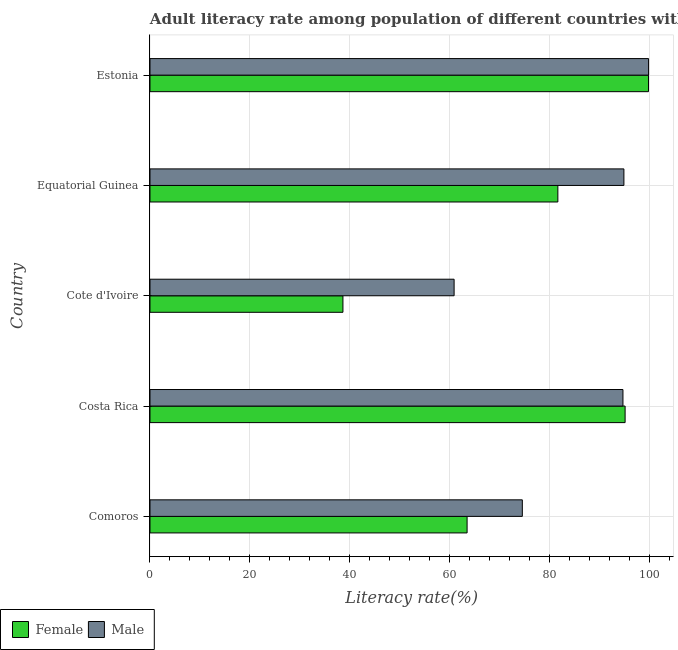How many groups of bars are there?
Give a very brief answer. 5. Are the number of bars on each tick of the Y-axis equal?
Keep it short and to the point. Yes. How many bars are there on the 2nd tick from the top?
Provide a short and direct response. 2. How many bars are there on the 3rd tick from the bottom?
Your answer should be very brief. 2. What is the label of the 5th group of bars from the top?
Make the answer very short. Comoros. In how many cases, is the number of bars for a given country not equal to the number of legend labels?
Make the answer very short. 0. What is the female adult literacy rate in Cote d'Ivoire?
Offer a terse response. 38.61. Across all countries, what is the maximum female adult literacy rate?
Make the answer very short. 99.76. Across all countries, what is the minimum female adult literacy rate?
Keep it short and to the point. 38.61. In which country was the female adult literacy rate maximum?
Ensure brevity in your answer.  Estonia. In which country was the male adult literacy rate minimum?
Make the answer very short. Cote d'Ivoire. What is the total female adult literacy rate in the graph?
Your response must be concise. 378.54. What is the difference between the male adult literacy rate in Costa Rica and that in Equatorial Guinea?
Make the answer very short. -0.19. What is the difference between the female adult literacy rate in Equatorial Guinea and the male adult literacy rate in Comoros?
Your response must be concise. 7.11. What is the average male adult literacy rate per country?
Give a very brief answer. 84.93. What is the difference between the male adult literacy rate and female adult literacy rate in Costa Rica?
Provide a short and direct response. -0.43. In how many countries, is the male adult literacy rate greater than 84 %?
Keep it short and to the point. 3. What is the ratio of the female adult literacy rate in Cote d'Ivoire to that in Estonia?
Offer a terse response. 0.39. Is the male adult literacy rate in Cote d'Ivoire less than that in Equatorial Guinea?
Keep it short and to the point. Yes. What is the difference between the highest and the second highest female adult literacy rate?
Give a very brief answer. 4.68. What is the difference between the highest and the lowest female adult literacy rate?
Ensure brevity in your answer.  61.15. Is the sum of the male adult literacy rate in Cote d'Ivoire and Estonia greater than the maximum female adult literacy rate across all countries?
Ensure brevity in your answer.  Yes. What does the 1st bar from the bottom in Estonia represents?
Keep it short and to the point. Female. Are all the bars in the graph horizontal?
Your answer should be very brief. Yes. What is the difference between two consecutive major ticks on the X-axis?
Provide a succinct answer. 20. Does the graph contain grids?
Keep it short and to the point. Yes. How many legend labels are there?
Make the answer very short. 2. What is the title of the graph?
Offer a terse response. Adult literacy rate among population of different countries with age above 15years. What is the label or title of the X-axis?
Offer a very short reply. Literacy rate(%). What is the Literacy rate(%) of Female in Comoros?
Give a very brief answer. 63.46. What is the Literacy rate(%) in Male in Comoros?
Your answer should be very brief. 74.51. What is the Literacy rate(%) in Female in Costa Rica?
Ensure brevity in your answer.  95.08. What is the Literacy rate(%) in Male in Costa Rica?
Your answer should be compact. 94.65. What is the Literacy rate(%) of Female in Cote d'Ivoire?
Your response must be concise. 38.61. What is the Literacy rate(%) in Male in Cote d'Ivoire?
Provide a short and direct response. 60.86. What is the Literacy rate(%) in Female in Equatorial Guinea?
Keep it short and to the point. 81.62. What is the Literacy rate(%) in Male in Equatorial Guinea?
Make the answer very short. 94.84. What is the Literacy rate(%) in Female in Estonia?
Your answer should be very brief. 99.76. What is the Literacy rate(%) in Male in Estonia?
Provide a short and direct response. 99.78. Across all countries, what is the maximum Literacy rate(%) of Female?
Your response must be concise. 99.76. Across all countries, what is the maximum Literacy rate(%) of Male?
Offer a terse response. 99.78. Across all countries, what is the minimum Literacy rate(%) in Female?
Keep it short and to the point. 38.61. Across all countries, what is the minimum Literacy rate(%) in Male?
Keep it short and to the point. 60.86. What is the total Literacy rate(%) in Female in the graph?
Make the answer very short. 378.54. What is the total Literacy rate(%) of Male in the graph?
Offer a terse response. 424.64. What is the difference between the Literacy rate(%) in Female in Comoros and that in Costa Rica?
Keep it short and to the point. -31.62. What is the difference between the Literacy rate(%) in Male in Comoros and that in Costa Rica?
Ensure brevity in your answer.  -20.14. What is the difference between the Literacy rate(%) of Female in Comoros and that in Cote d'Ivoire?
Offer a very short reply. 24.84. What is the difference between the Literacy rate(%) of Male in Comoros and that in Cote d'Ivoire?
Your response must be concise. 13.65. What is the difference between the Literacy rate(%) of Female in Comoros and that in Equatorial Guinea?
Make the answer very short. -18.16. What is the difference between the Literacy rate(%) in Male in Comoros and that in Equatorial Guinea?
Offer a terse response. -20.33. What is the difference between the Literacy rate(%) of Female in Comoros and that in Estonia?
Keep it short and to the point. -36.3. What is the difference between the Literacy rate(%) of Male in Comoros and that in Estonia?
Your answer should be compact. -25.26. What is the difference between the Literacy rate(%) in Female in Costa Rica and that in Cote d'Ivoire?
Ensure brevity in your answer.  56.47. What is the difference between the Literacy rate(%) of Male in Costa Rica and that in Cote d'Ivoire?
Your response must be concise. 33.79. What is the difference between the Literacy rate(%) in Female in Costa Rica and that in Equatorial Guinea?
Give a very brief answer. 13.46. What is the difference between the Literacy rate(%) in Male in Costa Rica and that in Equatorial Guinea?
Your answer should be compact. -0.19. What is the difference between the Literacy rate(%) of Female in Costa Rica and that in Estonia?
Your response must be concise. -4.68. What is the difference between the Literacy rate(%) of Male in Costa Rica and that in Estonia?
Give a very brief answer. -5.13. What is the difference between the Literacy rate(%) in Female in Cote d'Ivoire and that in Equatorial Guinea?
Your response must be concise. -43.01. What is the difference between the Literacy rate(%) of Male in Cote d'Ivoire and that in Equatorial Guinea?
Give a very brief answer. -33.98. What is the difference between the Literacy rate(%) in Female in Cote d'Ivoire and that in Estonia?
Provide a succinct answer. -61.15. What is the difference between the Literacy rate(%) in Male in Cote d'Ivoire and that in Estonia?
Ensure brevity in your answer.  -38.92. What is the difference between the Literacy rate(%) in Female in Equatorial Guinea and that in Estonia?
Your answer should be compact. -18.14. What is the difference between the Literacy rate(%) in Male in Equatorial Guinea and that in Estonia?
Your response must be concise. -4.93. What is the difference between the Literacy rate(%) of Female in Comoros and the Literacy rate(%) of Male in Costa Rica?
Offer a terse response. -31.19. What is the difference between the Literacy rate(%) of Female in Comoros and the Literacy rate(%) of Male in Cote d'Ivoire?
Give a very brief answer. 2.6. What is the difference between the Literacy rate(%) of Female in Comoros and the Literacy rate(%) of Male in Equatorial Guinea?
Keep it short and to the point. -31.38. What is the difference between the Literacy rate(%) of Female in Comoros and the Literacy rate(%) of Male in Estonia?
Your response must be concise. -36.32. What is the difference between the Literacy rate(%) of Female in Costa Rica and the Literacy rate(%) of Male in Cote d'Ivoire?
Provide a succinct answer. 34.22. What is the difference between the Literacy rate(%) of Female in Costa Rica and the Literacy rate(%) of Male in Equatorial Guinea?
Offer a very short reply. 0.24. What is the difference between the Literacy rate(%) in Female in Costa Rica and the Literacy rate(%) in Male in Estonia?
Your response must be concise. -4.7. What is the difference between the Literacy rate(%) in Female in Cote d'Ivoire and the Literacy rate(%) in Male in Equatorial Guinea?
Provide a short and direct response. -56.23. What is the difference between the Literacy rate(%) of Female in Cote d'Ivoire and the Literacy rate(%) of Male in Estonia?
Make the answer very short. -61.16. What is the difference between the Literacy rate(%) of Female in Equatorial Guinea and the Literacy rate(%) of Male in Estonia?
Your answer should be compact. -18.15. What is the average Literacy rate(%) of Female per country?
Give a very brief answer. 75.71. What is the average Literacy rate(%) in Male per country?
Your response must be concise. 84.93. What is the difference between the Literacy rate(%) of Female and Literacy rate(%) of Male in Comoros?
Provide a succinct answer. -11.05. What is the difference between the Literacy rate(%) of Female and Literacy rate(%) of Male in Costa Rica?
Your answer should be very brief. 0.43. What is the difference between the Literacy rate(%) of Female and Literacy rate(%) of Male in Cote d'Ivoire?
Provide a short and direct response. -22.25. What is the difference between the Literacy rate(%) in Female and Literacy rate(%) in Male in Equatorial Guinea?
Your response must be concise. -13.22. What is the difference between the Literacy rate(%) of Female and Literacy rate(%) of Male in Estonia?
Make the answer very short. -0.02. What is the ratio of the Literacy rate(%) in Female in Comoros to that in Costa Rica?
Provide a succinct answer. 0.67. What is the ratio of the Literacy rate(%) of Male in Comoros to that in Costa Rica?
Give a very brief answer. 0.79. What is the ratio of the Literacy rate(%) of Female in Comoros to that in Cote d'Ivoire?
Ensure brevity in your answer.  1.64. What is the ratio of the Literacy rate(%) of Male in Comoros to that in Cote d'Ivoire?
Provide a short and direct response. 1.22. What is the ratio of the Literacy rate(%) of Female in Comoros to that in Equatorial Guinea?
Offer a terse response. 0.78. What is the ratio of the Literacy rate(%) in Male in Comoros to that in Equatorial Guinea?
Your response must be concise. 0.79. What is the ratio of the Literacy rate(%) in Female in Comoros to that in Estonia?
Offer a terse response. 0.64. What is the ratio of the Literacy rate(%) in Male in Comoros to that in Estonia?
Your answer should be very brief. 0.75. What is the ratio of the Literacy rate(%) in Female in Costa Rica to that in Cote d'Ivoire?
Ensure brevity in your answer.  2.46. What is the ratio of the Literacy rate(%) of Male in Costa Rica to that in Cote d'Ivoire?
Ensure brevity in your answer.  1.56. What is the ratio of the Literacy rate(%) of Female in Costa Rica to that in Equatorial Guinea?
Make the answer very short. 1.16. What is the ratio of the Literacy rate(%) in Male in Costa Rica to that in Equatorial Guinea?
Offer a terse response. 1. What is the ratio of the Literacy rate(%) of Female in Costa Rica to that in Estonia?
Provide a succinct answer. 0.95. What is the ratio of the Literacy rate(%) of Male in Costa Rica to that in Estonia?
Your response must be concise. 0.95. What is the ratio of the Literacy rate(%) in Female in Cote d'Ivoire to that in Equatorial Guinea?
Your response must be concise. 0.47. What is the ratio of the Literacy rate(%) in Male in Cote d'Ivoire to that in Equatorial Guinea?
Your answer should be very brief. 0.64. What is the ratio of the Literacy rate(%) of Female in Cote d'Ivoire to that in Estonia?
Give a very brief answer. 0.39. What is the ratio of the Literacy rate(%) in Male in Cote d'Ivoire to that in Estonia?
Offer a very short reply. 0.61. What is the ratio of the Literacy rate(%) of Female in Equatorial Guinea to that in Estonia?
Keep it short and to the point. 0.82. What is the ratio of the Literacy rate(%) of Male in Equatorial Guinea to that in Estonia?
Offer a very short reply. 0.95. What is the difference between the highest and the second highest Literacy rate(%) in Female?
Make the answer very short. 4.68. What is the difference between the highest and the second highest Literacy rate(%) of Male?
Your answer should be compact. 4.93. What is the difference between the highest and the lowest Literacy rate(%) of Female?
Your answer should be compact. 61.15. What is the difference between the highest and the lowest Literacy rate(%) of Male?
Your answer should be very brief. 38.92. 